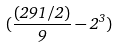<formula> <loc_0><loc_0><loc_500><loc_500>( \frac { ( 2 9 1 / 2 ) } { 9 } - 2 ^ { 3 } )</formula> 